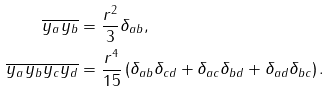Convert formula to latex. <formula><loc_0><loc_0><loc_500><loc_500>\overline { y _ { a } y _ { b } } & = \frac { r ^ { 2 } } { 3 } \delta _ { a b } , \\ \overline { y _ { a } y _ { b } y _ { c } y _ { d } } & = \frac { r ^ { 4 } } { 1 5 } \left ( \delta _ { a b } \delta _ { c d } + \delta _ { a c } \delta _ { b d } + \delta _ { a d } \delta _ { b c } \right ) .</formula> 